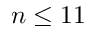Convert formula to latex. <formula><loc_0><loc_0><loc_500><loc_500>n \leq 1 1</formula> 